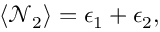<formula> <loc_0><loc_0><loc_500><loc_500>\begin{array} { r } { \langle \mathcal { N } _ { 2 } \rangle = \epsilon _ { 1 } + \epsilon _ { 2 } , } \end{array}</formula> 